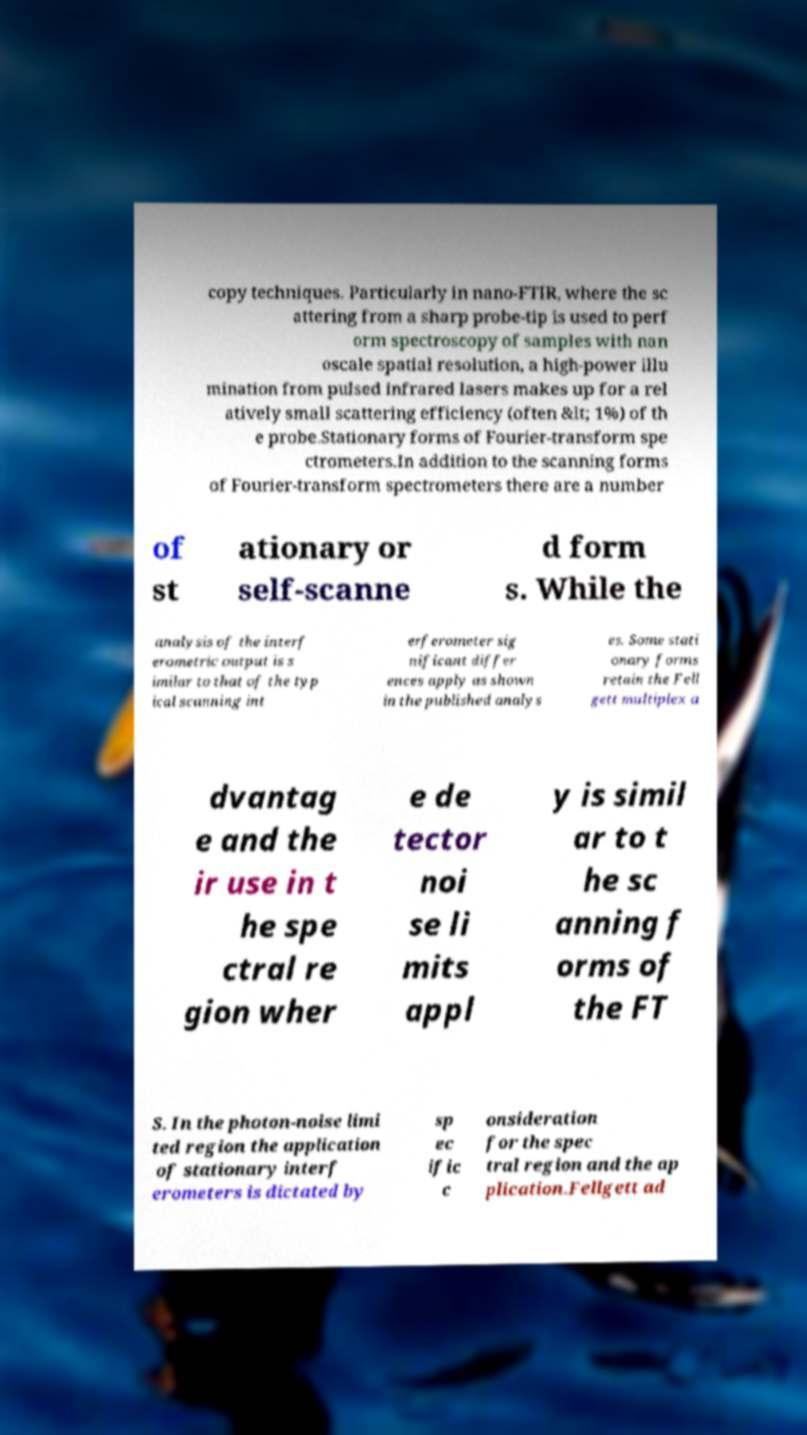Please read and relay the text visible in this image. What does it say? copy techniques. Particularly in nano-FTIR, where the sc attering from a sharp probe-tip is used to perf orm spectroscopy of samples with nan oscale spatial resolution, a high-power illu mination from pulsed infrared lasers makes up for a rel atively small scattering efficiency (often &lt; 1%) of th e probe.Stationary forms of Fourier-transform spe ctrometers.In addition to the scanning forms of Fourier-transform spectrometers there are a number of st ationary or self-scanne d form s. While the analysis of the interf erometric output is s imilar to that of the typ ical scanning int erferometer sig nificant differ ences apply as shown in the published analys es. Some stati onary forms retain the Fell gett multiplex a dvantag e and the ir use in t he spe ctral re gion wher e de tector noi se li mits appl y is simil ar to t he sc anning f orms of the FT S. In the photon-noise limi ted region the application of stationary interf erometers is dictated by sp ec ific c onsideration for the spec tral region and the ap plication.Fellgett ad 